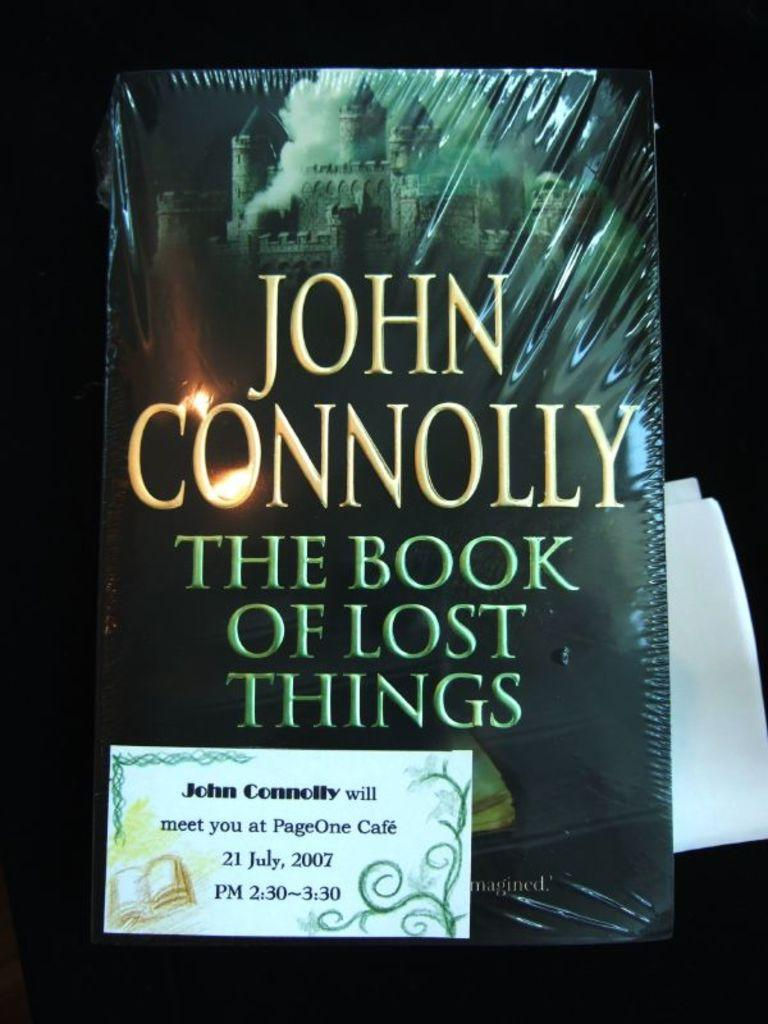Provide a one-sentence caption for the provided image. The Book of Lost Things that is written by John Connolly. 